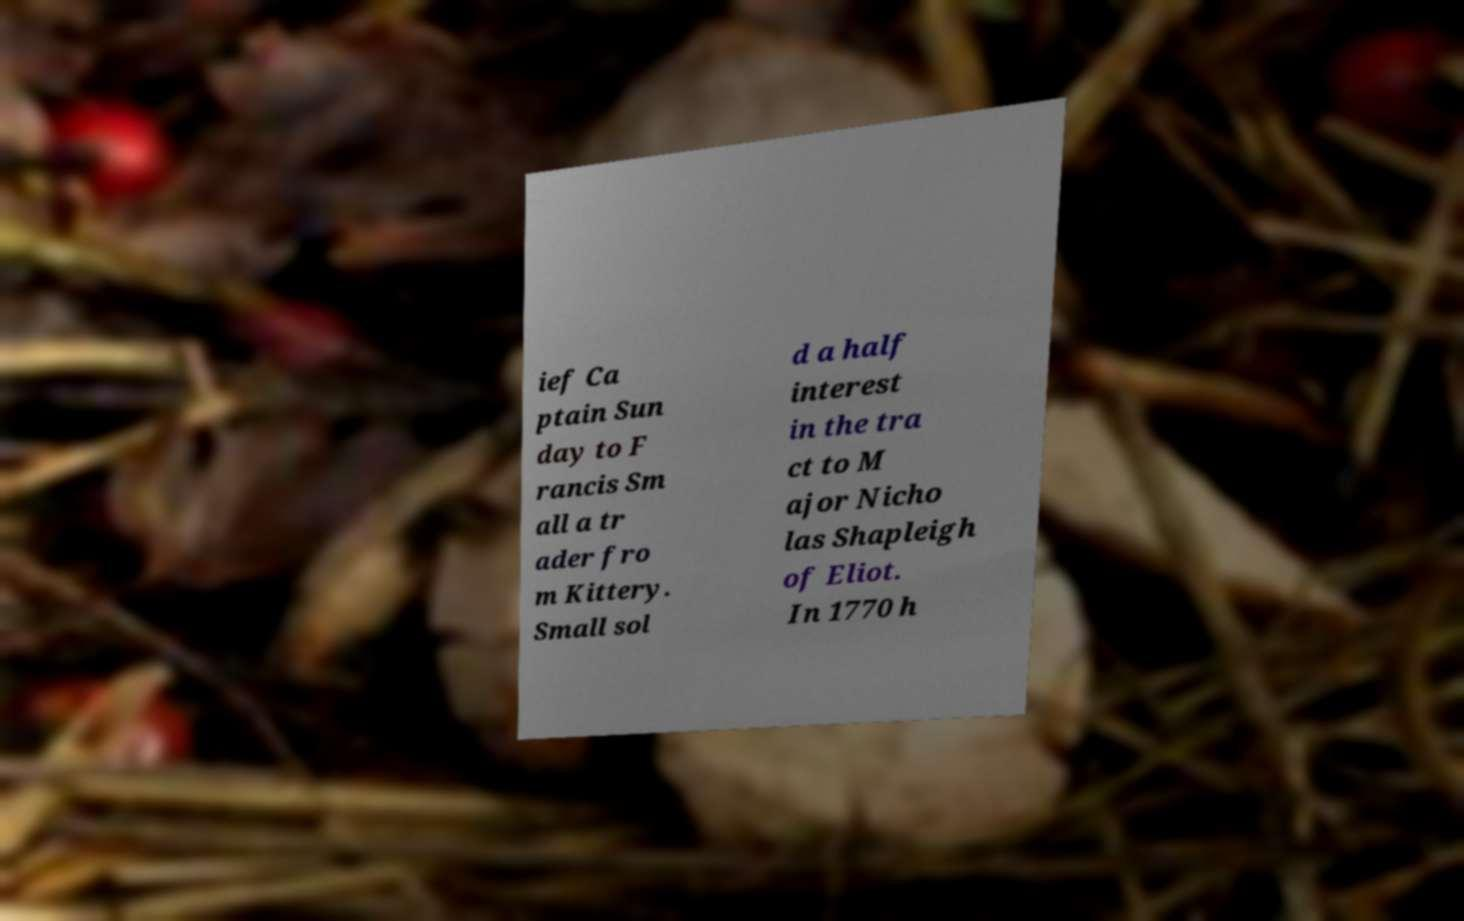For documentation purposes, I need the text within this image transcribed. Could you provide that? ief Ca ptain Sun day to F rancis Sm all a tr ader fro m Kittery. Small sol d a half interest in the tra ct to M ajor Nicho las Shapleigh of Eliot. In 1770 h 